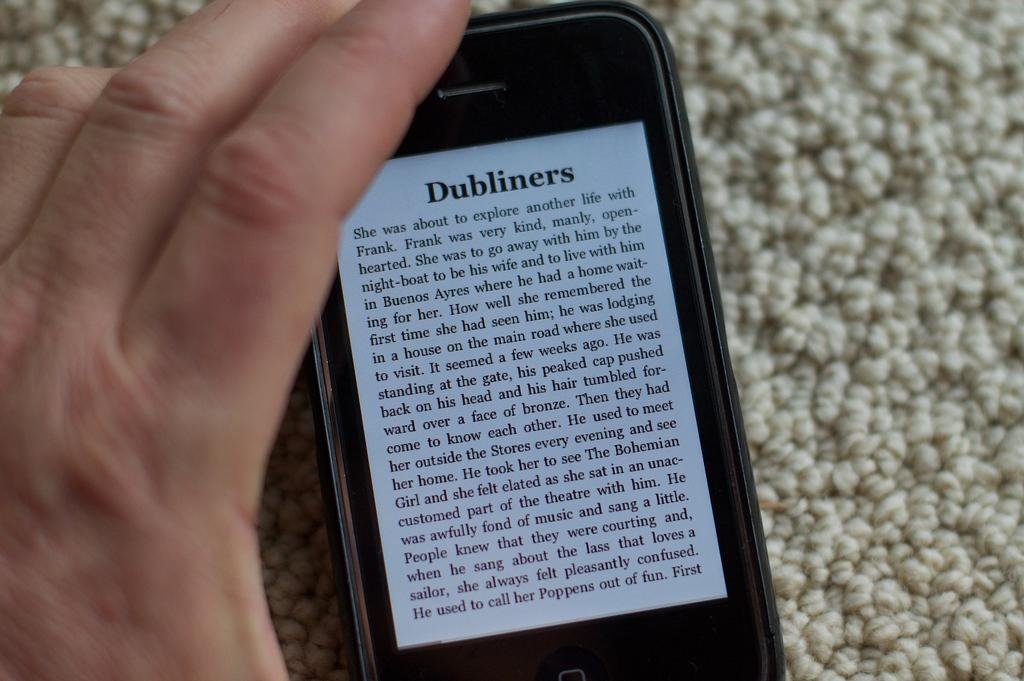<image>
Provide a brief description of the given image. A text on a smart phone that is titled Dubliners. 